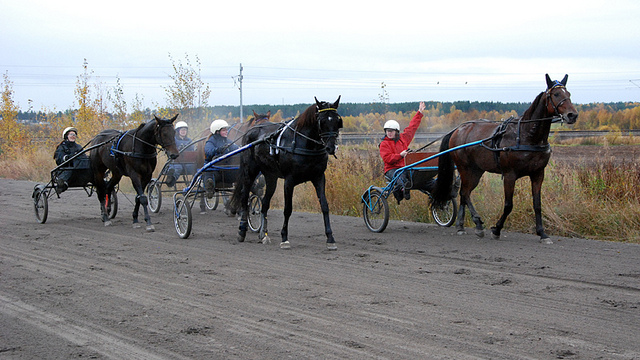<image>Which of the horses legs has white fur? There is no horse with white fur on its legs in the image. Which of the horses legs has white fur? It is unknown which of the horses legs has white fur. None of them have white fur. 